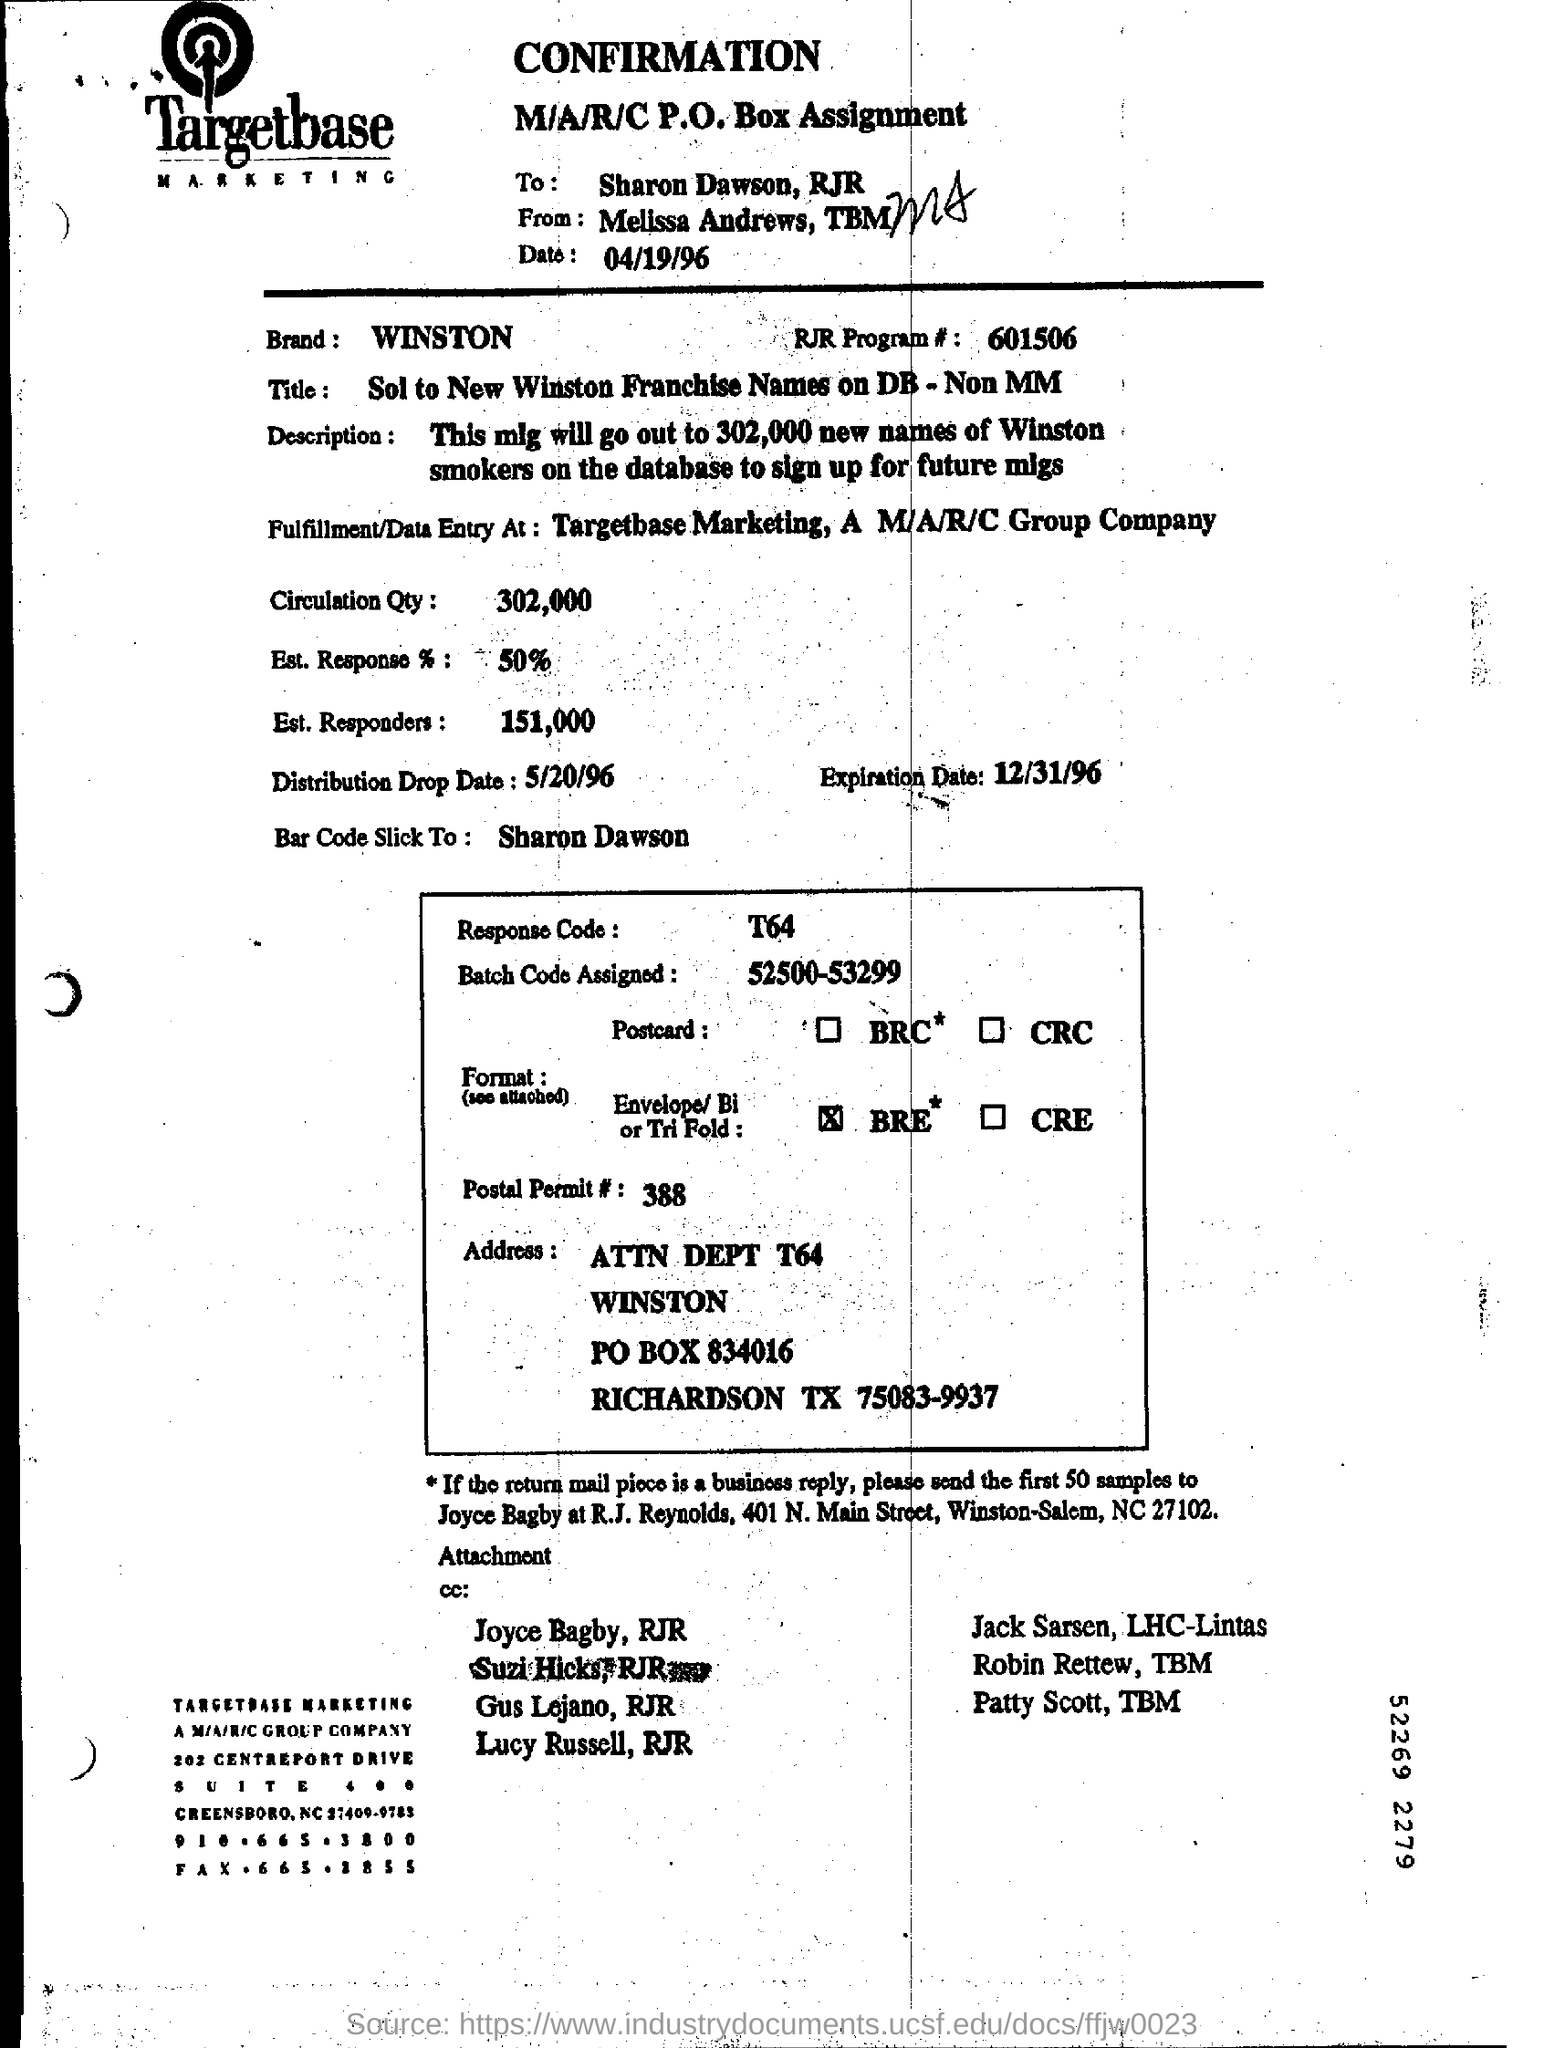Who is it addressed to?
Your answer should be compact. Sharon Dawson, RJR. Which brand is mentioned in the form?
Provide a succinct answer. WINSTON. What is the Date?
Your response must be concise. 04/19/96. What is the Brand?
Your response must be concise. Winston. What is the RJR Program #?
Ensure brevity in your answer.  601506. What is the Circulation Qty?
Provide a succinct answer. 302,000. What is the Est. Response %?
Ensure brevity in your answer.  50. What is the Est. Responders?
Offer a very short reply. 151,000. When is the Distribution Drop Date?
Provide a short and direct response. 5/20/96. When is the Expiration Date?
Give a very brief answer. 12/31/96. 